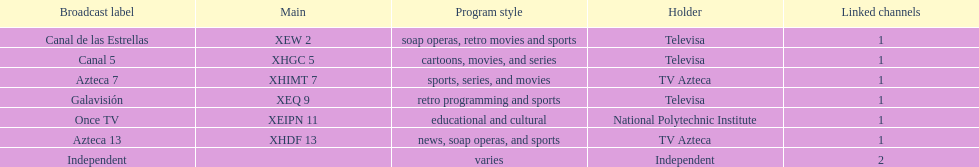What is the number of networks that are owned by televisa? 3. 